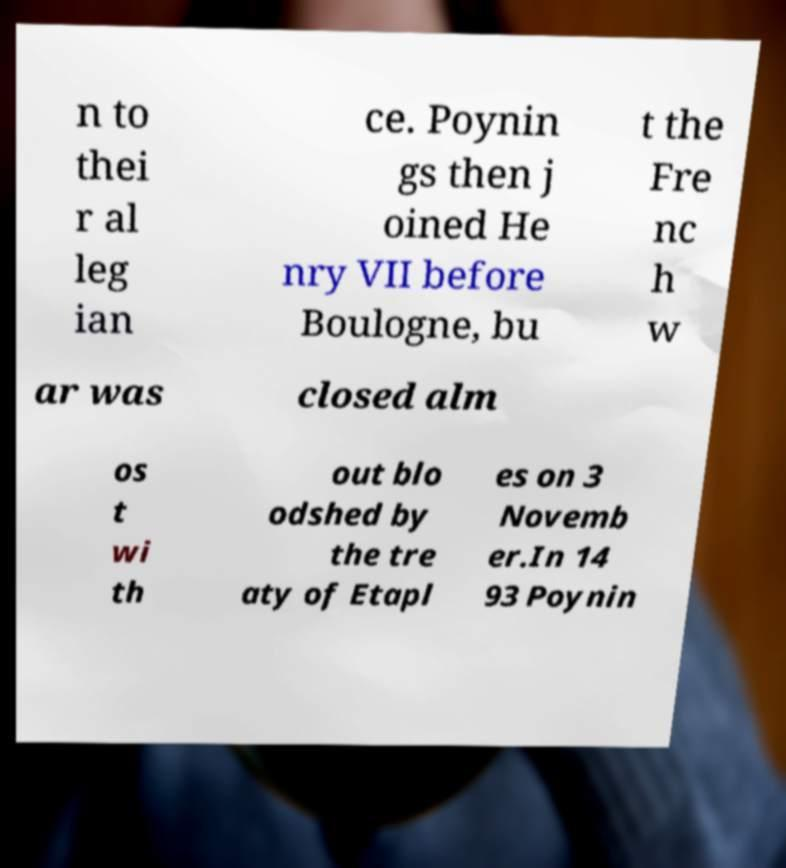There's text embedded in this image that I need extracted. Can you transcribe it verbatim? n to thei r al leg ian ce. Poynin gs then j oined He nry VII before Boulogne, bu t the Fre nc h w ar was closed alm os t wi th out blo odshed by the tre aty of Etapl es on 3 Novemb er.In 14 93 Poynin 